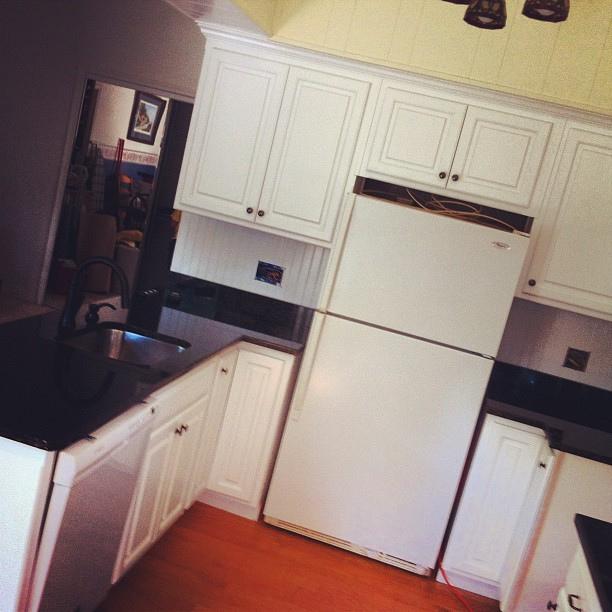Is the countertop the same color as the cabinets?
Keep it brief. No. What color is the fridge?
Answer briefly. White. Is the fridge open?
Answer briefly. No. 